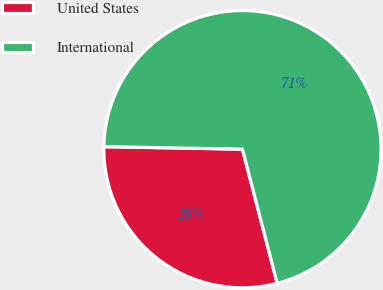Convert chart to OTSL. <chart><loc_0><loc_0><loc_500><loc_500><pie_chart><fcel>United States<fcel>International<nl><fcel>29.32%<fcel>70.68%<nl></chart> 